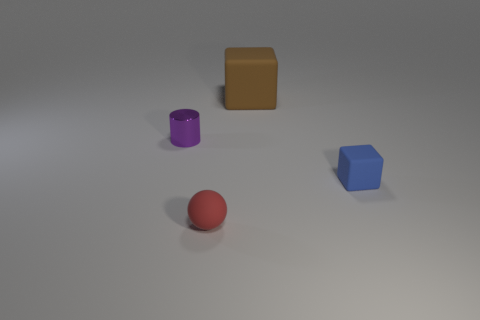How many shiny objects are either small cyan cylinders or small balls?
Your response must be concise. 0. Is there a red rubber thing that has the same size as the blue block?
Your answer should be very brief. Yes. Is the number of tiny purple shiny cylinders that are to the left of the tiny cylinder greater than the number of cyan rubber objects?
Offer a terse response. No. How many big objects are either blue metal blocks or brown rubber blocks?
Keep it short and to the point. 1. What number of small metallic objects are the same shape as the big object?
Make the answer very short. 0. The tiny object that is in front of the matte block that is on the right side of the big matte object is made of what material?
Offer a terse response. Rubber. There is a matte thing that is on the right side of the large matte block; what size is it?
Provide a short and direct response. Small. How many blue things are cylinders or small objects?
Make the answer very short. 1. Is there anything else that is the same material as the large cube?
Keep it short and to the point. Yes. There is a brown object that is the same shape as the small blue object; what material is it?
Your response must be concise. Rubber. 